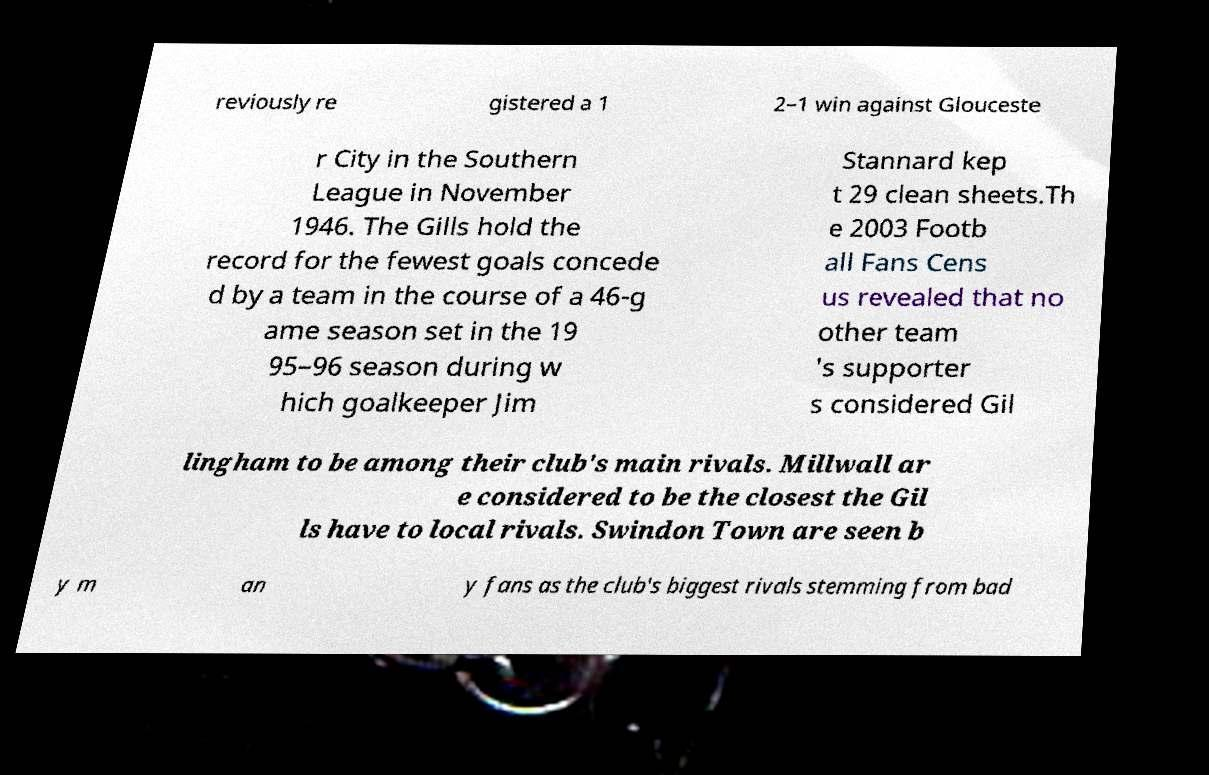Could you extract and type out the text from this image? reviously re gistered a 1 2–1 win against Glouceste r City in the Southern League in November 1946. The Gills hold the record for the fewest goals concede d by a team in the course of a 46-g ame season set in the 19 95–96 season during w hich goalkeeper Jim Stannard kep t 29 clean sheets.Th e 2003 Footb all Fans Cens us revealed that no other team 's supporter s considered Gil lingham to be among their club's main rivals. Millwall ar e considered to be the closest the Gil ls have to local rivals. Swindon Town are seen b y m an y fans as the club's biggest rivals stemming from bad 